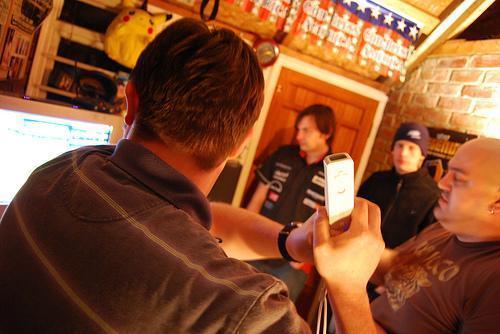How many men are in there?
Give a very brief answer. 4. 